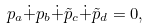Convert formula to latex. <formula><loc_0><loc_0><loc_500><loc_500>p _ { a } \dot { + } p _ { b } \dot { + } { \tilde { p } } _ { c } \dot { + } { \tilde { p } } _ { d } = 0 ,</formula> 